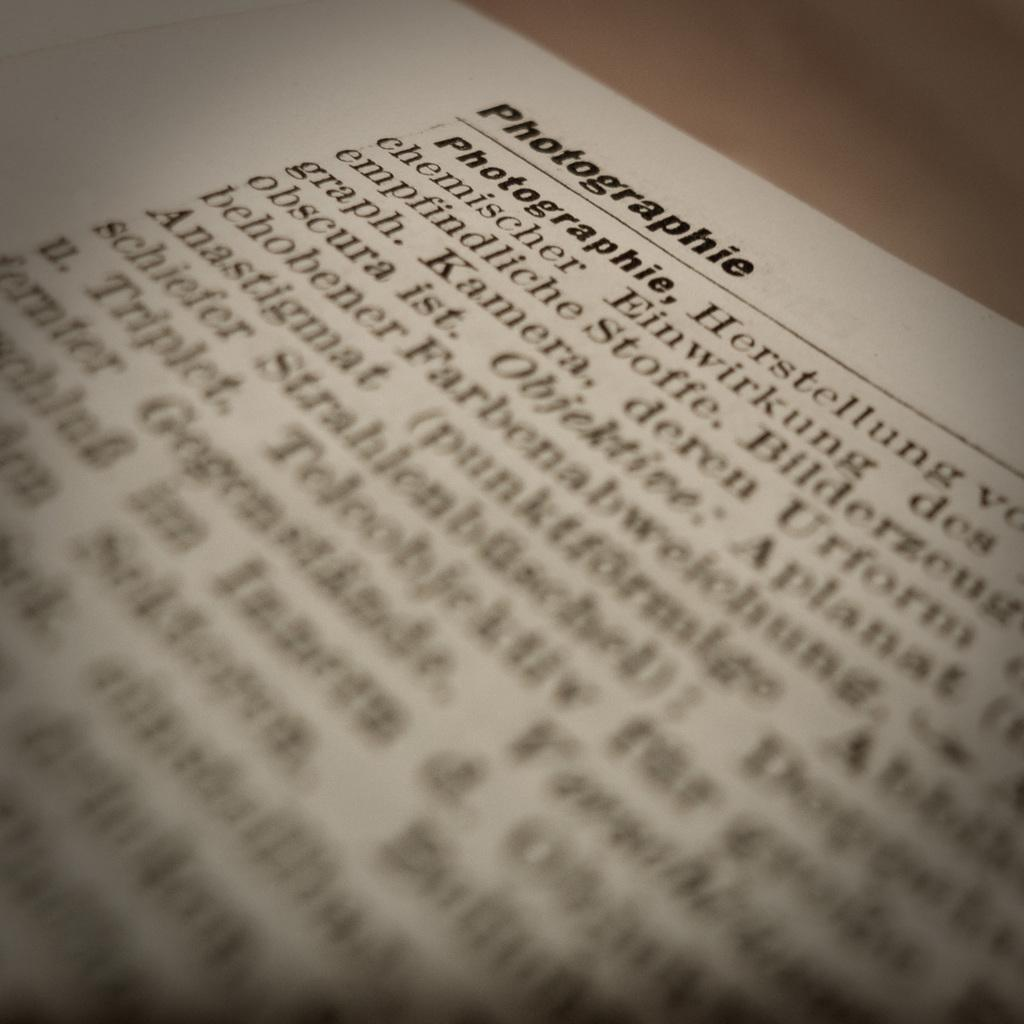<image>
Describe the image concisely. A piece of paper has information about Photographie written on it in German 